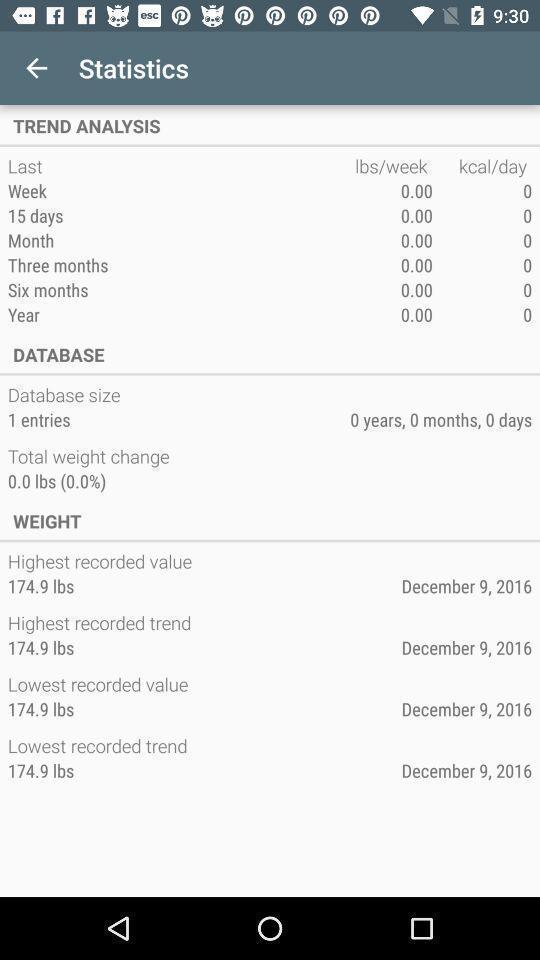Tell me about the visual elements in this screen capture. Page displaying the statistics. 